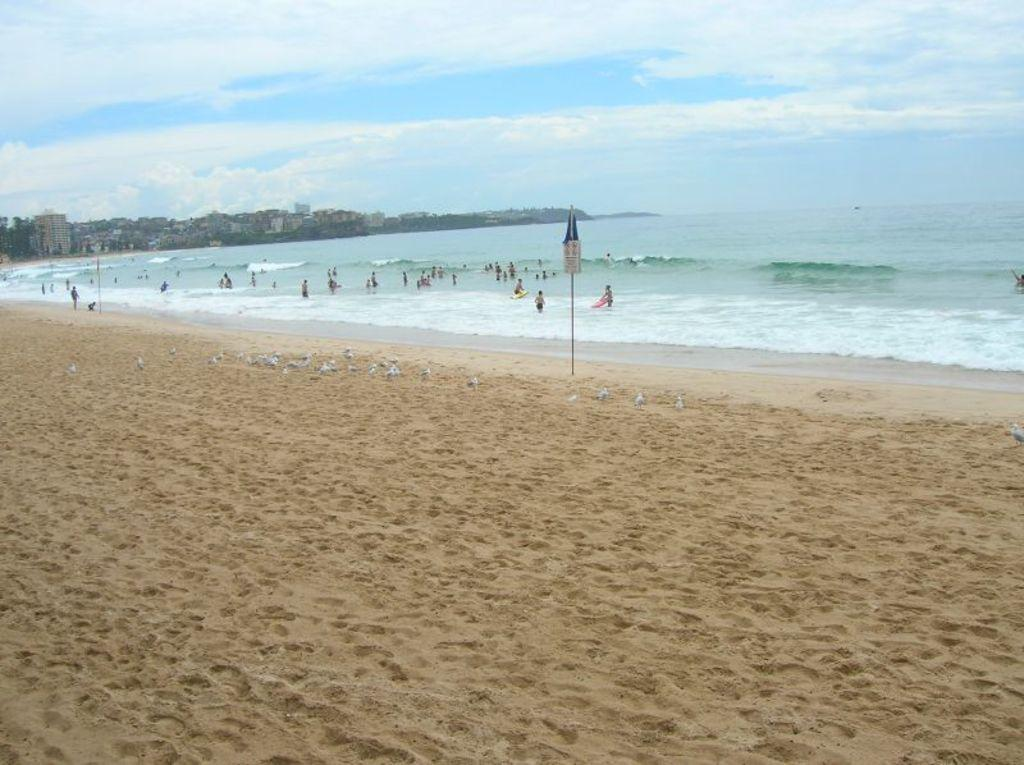What is on the ground in the center of the image? There is sand on the ground in the center of the image. What are the persons in the image doing? The persons are in the water in the background of the image. What can be seen in the distance in the image? There are buildings visible in the background of the image. How would you describe the weather in the image? The sky is cloudy in the image, suggesting a potentially overcast or rainy day. What type of cake is being served on the sand in the image? There is no cake present in the image; it features sand on the ground and persons in the water. 